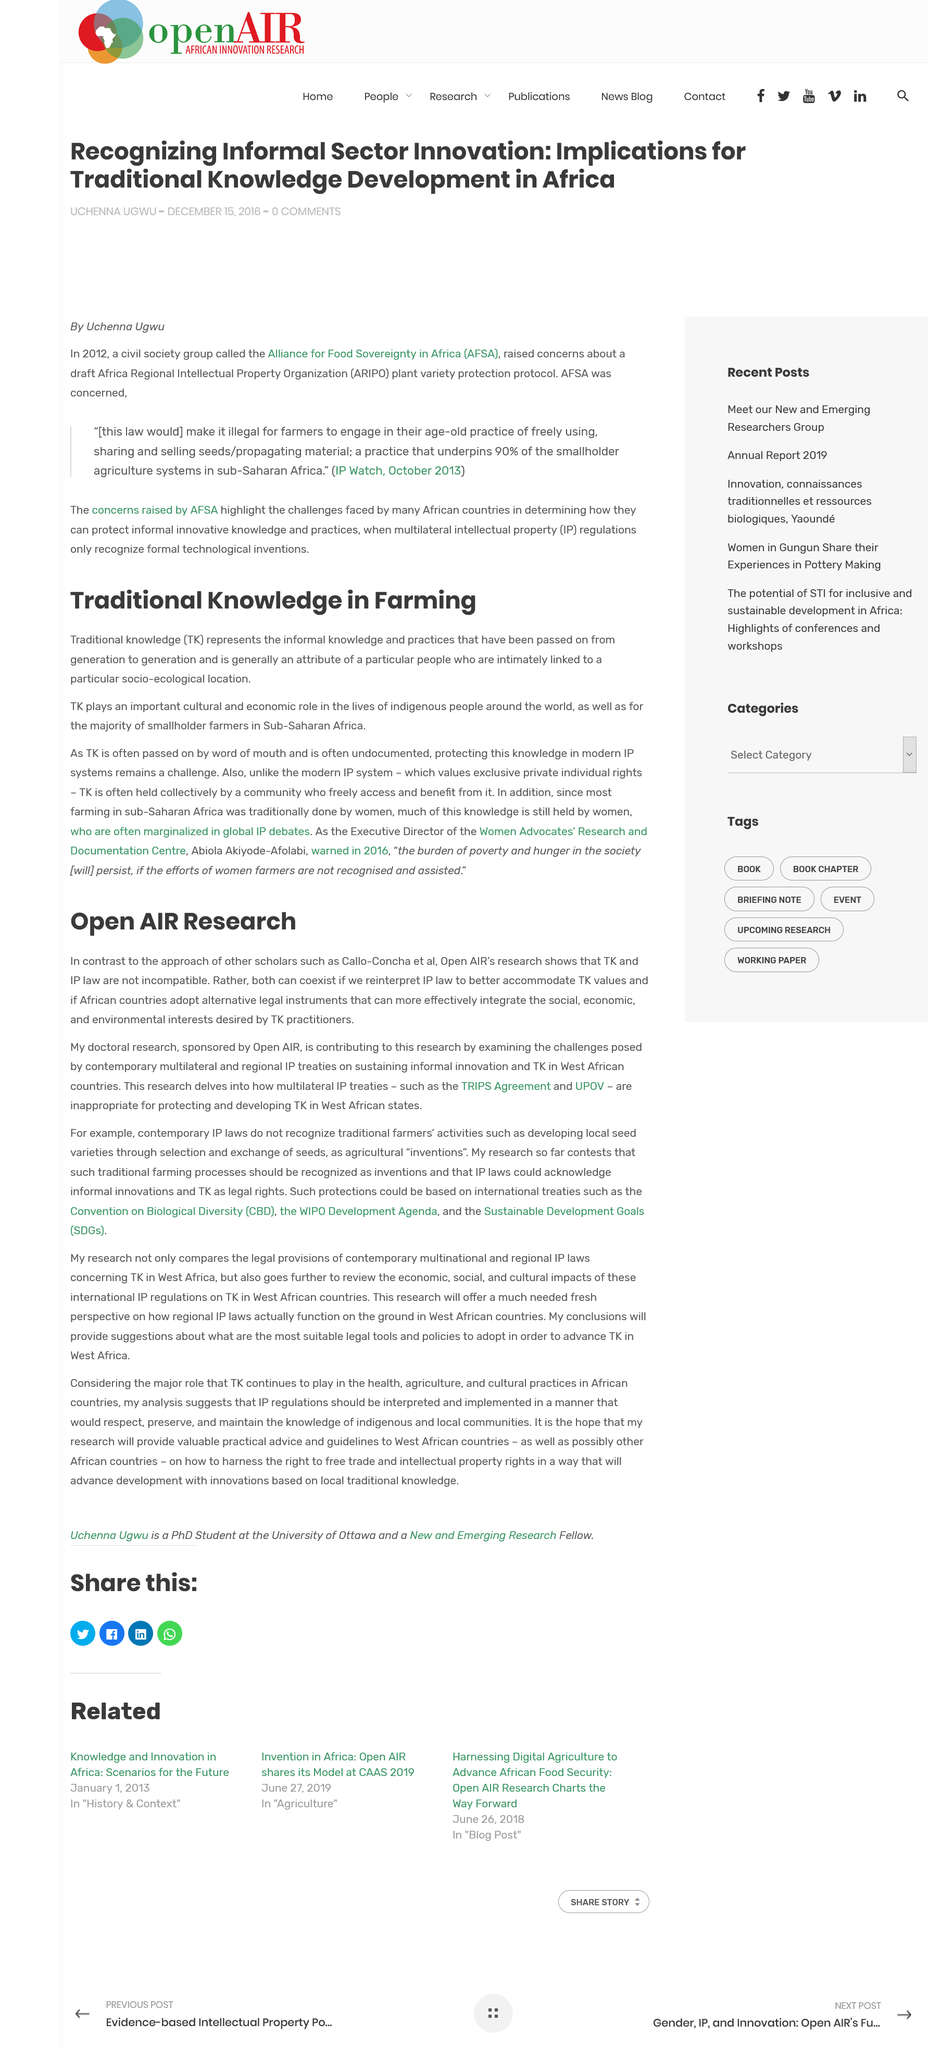Identify some key points in this picture. Traditional knowledge, often abbreviated as TK, is a term used to refer to the skills, practices, and knowledge systems used by Indigenous peoples and local communities to manage and use the natural resources around them. TK encompasses a wide range of knowledge, including traditional medicinal remedies, agricultural techniques, and environmental management practices. It is widely recognized as a valuable and essential component of cultural heritage, and is protected by international law. In the lives of indigenous people around the world, TK plays a crucial cultural and economic role that cannot be overstated. This doctoral research examines the challenges posed by contemporary multilateral and regional IP treaties, and how it is contributing to this research by providing insights into the complexities of these treaties and their impact on international trade. The research findings suggest that the TRIPS Agreement and UPOV are inadequate in protecting and promoting the development of traditional knowledge in West African states. Yes, TK represents the informal knowledge and practices that have been passed from generations. 